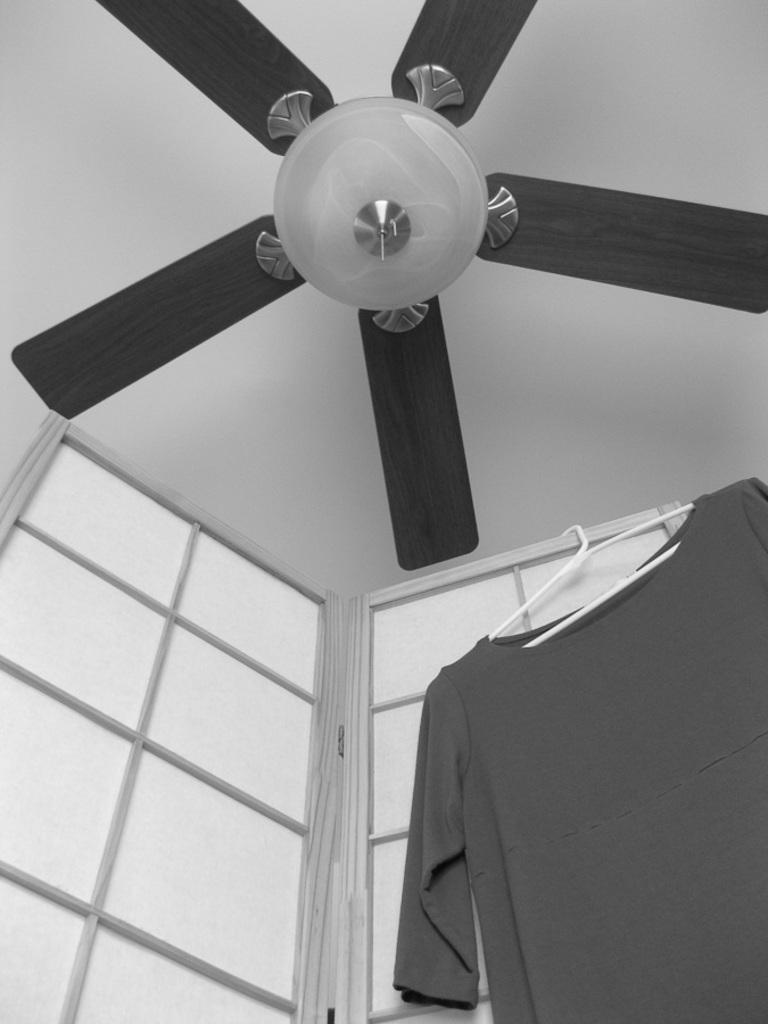What can be seen on the roof in the image? There is a fan on the roof. What type of clothing item is hanging in the image? There is a t-shirt hanging on a hanger. Where is the hanger located in relation to other objects in the image? The hanger is near to a door. Where is the frog sitting in the image? There is no frog present in the image. What type of food is being served in the lunchroom in the image? There is no lunchroom present in the image. 